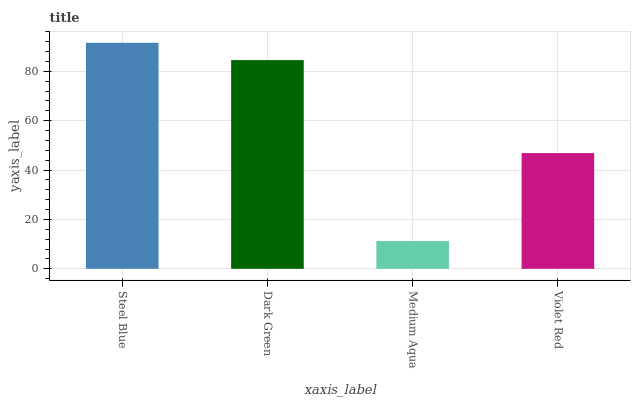Is Dark Green the minimum?
Answer yes or no. No. Is Dark Green the maximum?
Answer yes or no. No. Is Steel Blue greater than Dark Green?
Answer yes or no. Yes. Is Dark Green less than Steel Blue?
Answer yes or no. Yes. Is Dark Green greater than Steel Blue?
Answer yes or no. No. Is Steel Blue less than Dark Green?
Answer yes or no. No. Is Dark Green the high median?
Answer yes or no. Yes. Is Violet Red the low median?
Answer yes or no. Yes. Is Violet Red the high median?
Answer yes or no. No. Is Medium Aqua the low median?
Answer yes or no. No. 